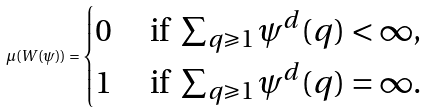Convert formula to latex. <formula><loc_0><loc_0><loc_500><loc_500>\mu ( W ( \psi ) ) = \begin{cases} 0 & \text { if } \sum _ { q \geqslant 1 } \psi ^ { d } ( q ) < \infty , \\ 1 & \text { if } \sum _ { q \geqslant 1 } \psi ^ { d } ( q ) = \infty . \end{cases}</formula> 